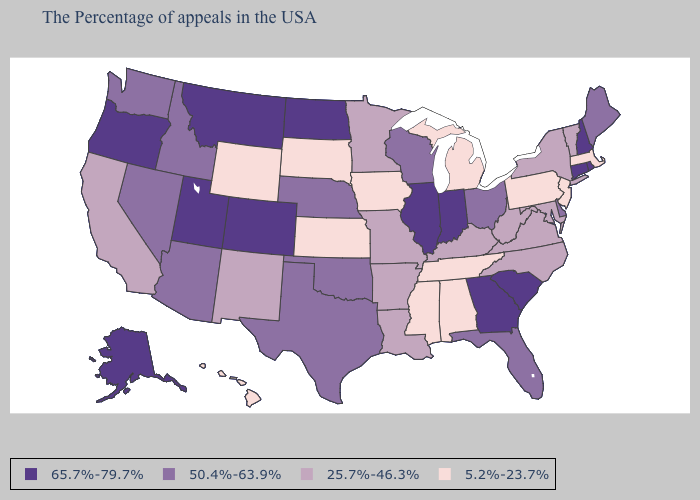Does North Dakota have the highest value in the USA?
Answer briefly. Yes. Does North Dakota have the highest value in the USA?
Quick response, please. Yes. Which states have the highest value in the USA?
Give a very brief answer. Rhode Island, New Hampshire, Connecticut, South Carolina, Georgia, Indiana, Illinois, North Dakota, Colorado, Utah, Montana, Oregon, Alaska. Among the states that border New Jersey , which have the highest value?
Give a very brief answer. Delaware. What is the highest value in states that border Louisiana?
Give a very brief answer. 50.4%-63.9%. Among the states that border Kansas , which have the highest value?
Give a very brief answer. Colorado. Is the legend a continuous bar?
Quick response, please. No. Which states have the lowest value in the USA?
Be succinct. Massachusetts, New Jersey, Pennsylvania, Michigan, Alabama, Tennessee, Mississippi, Iowa, Kansas, South Dakota, Wyoming, Hawaii. Is the legend a continuous bar?
Write a very short answer. No. What is the value of Texas?
Write a very short answer. 50.4%-63.9%. What is the highest value in the South ?
Keep it brief. 65.7%-79.7%. Name the states that have a value in the range 50.4%-63.9%?
Be succinct. Maine, Delaware, Ohio, Florida, Wisconsin, Nebraska, Oklahoma, Texas, Arizona, Idaho, Nevada, Washington. What is the highest value in the USA?
Quick response, please. 65.7%-79.7%. What is the lowest value in states that border Ohio?
Answer briefly. 5.2%-23.7%. 